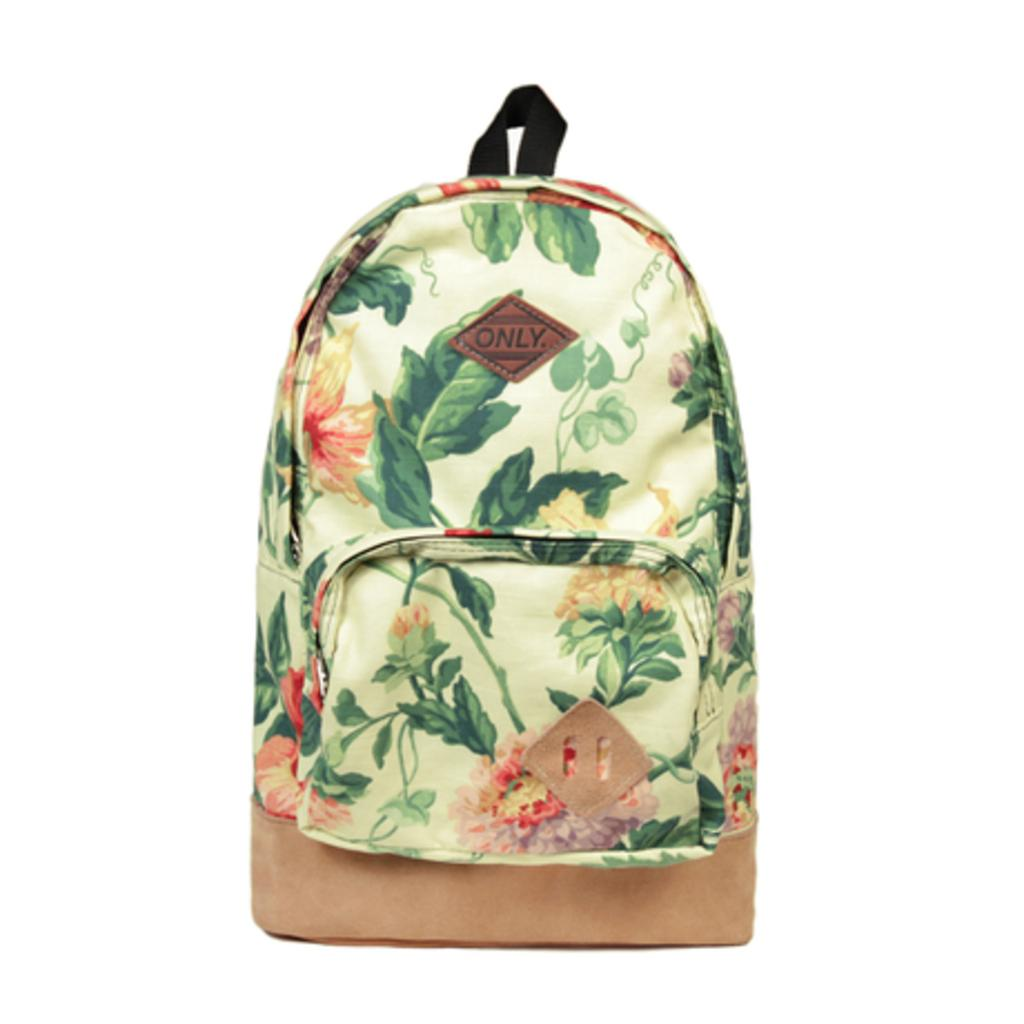<image>
Present a compact description of the photo's key features. An "Only" brand floral backpack with a front zipper pocket. 